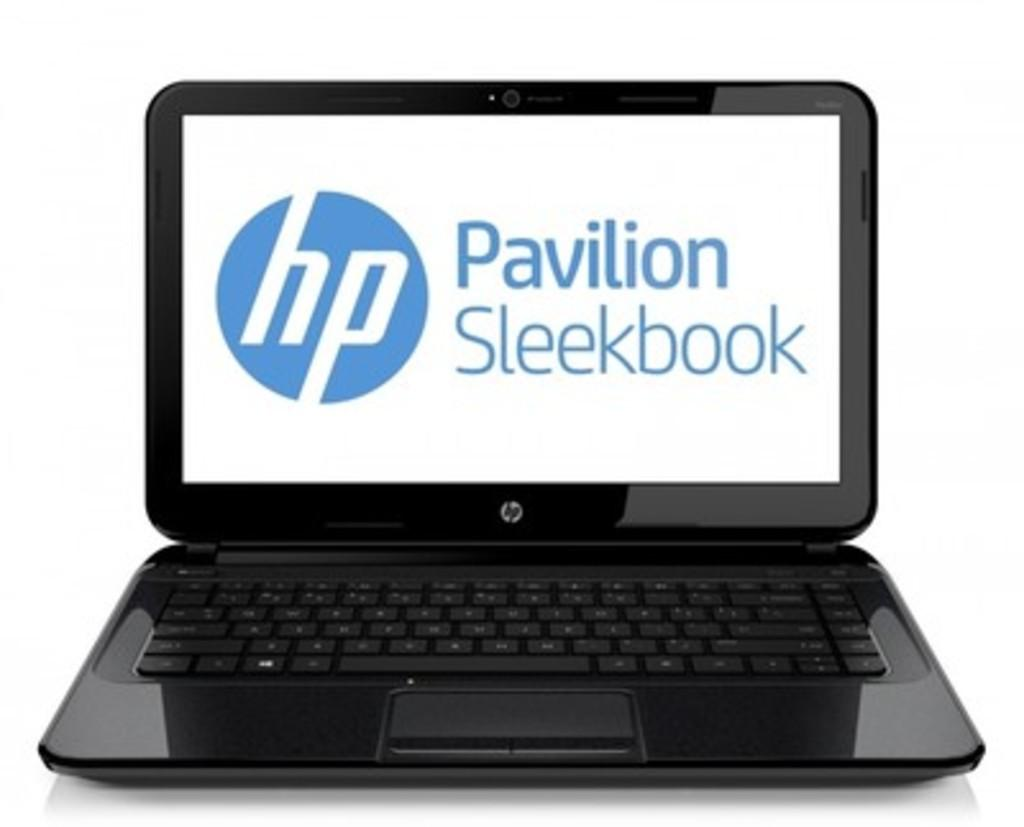<image>
Relay a brief, clear account of the picture shown. a laptop computer the brand is hp pavilion 